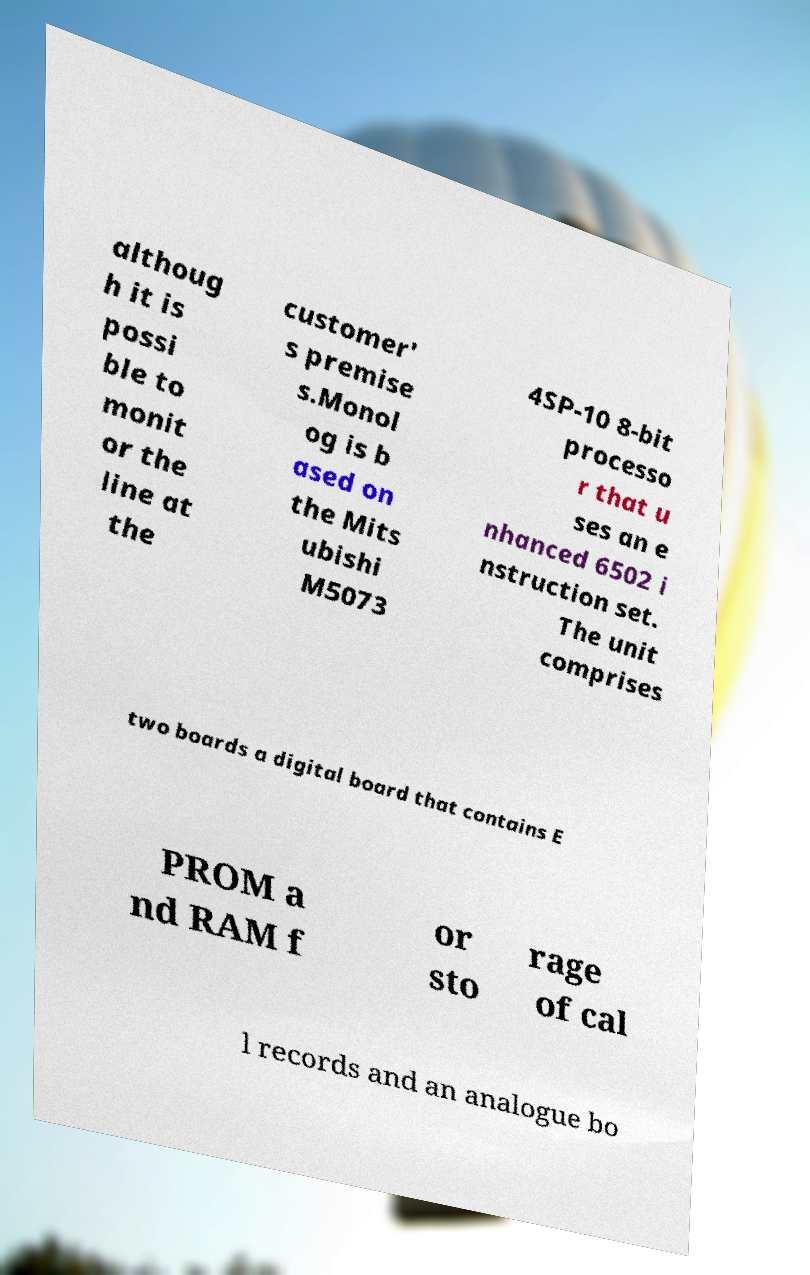What messages or text are displayed in this image? I need them in a readable, typed format. althoug h it is possi ble to monit or the line at the customer' s premise s.Monol og is b ased on the Mits ubishi M5073 4SP-10 8-bit processo r that u ses an e nhanced 6502 i nstruction set. The unit comprises two boards a digital board that contains E PROM a nd RAM f or sto rage of cal l records and an analogue bo 